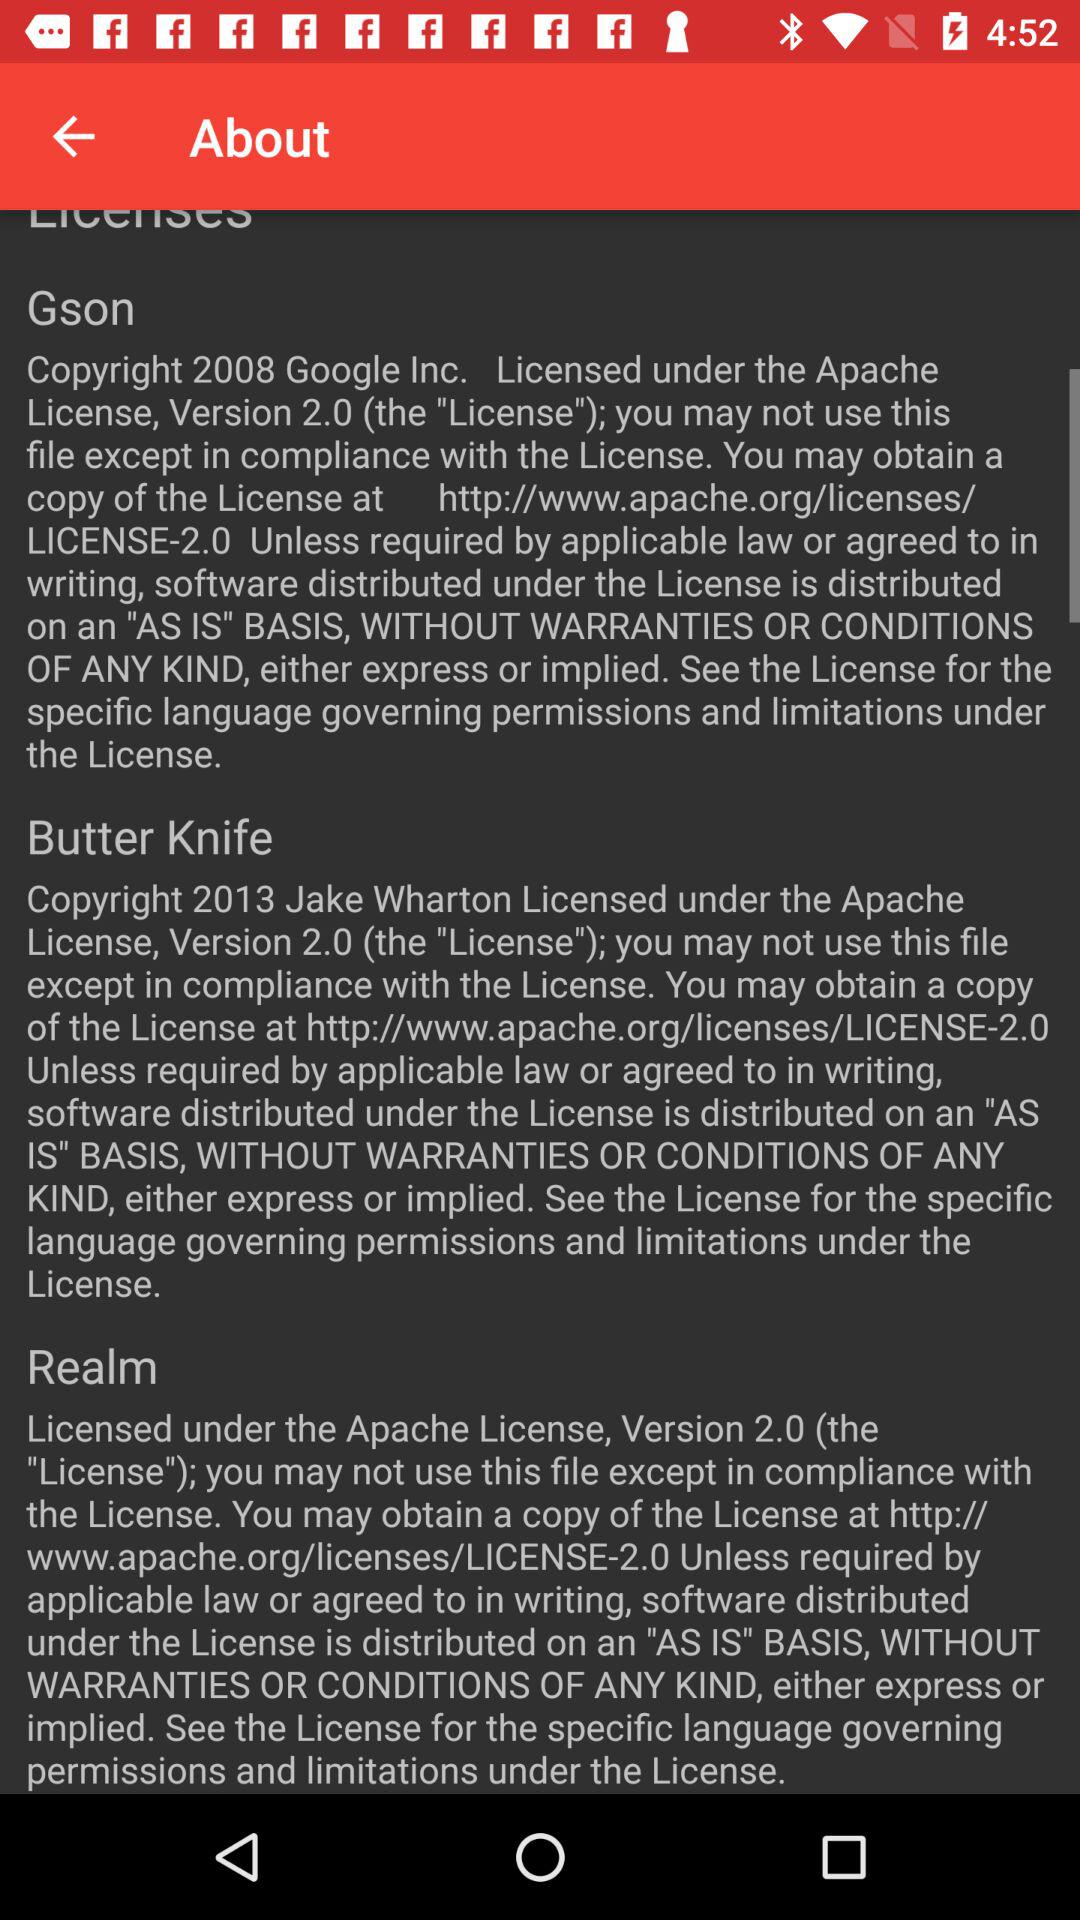What is the version of Gson? The version is 2.0. 